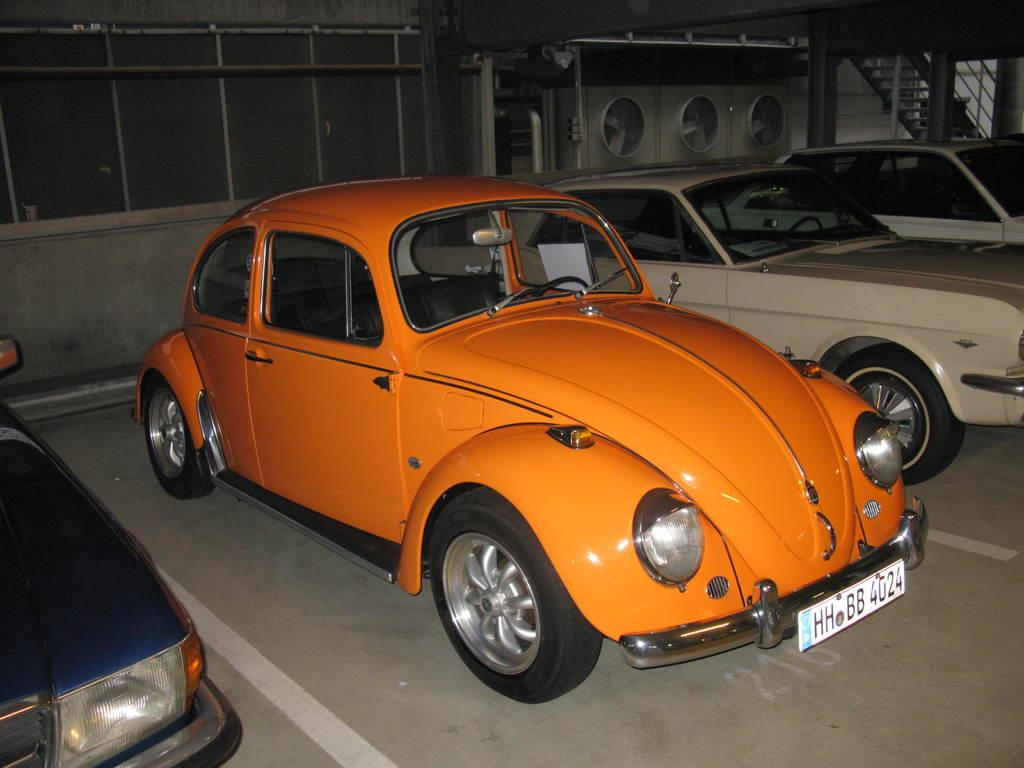What type of objects are featured in the image? There are model cars in the image. Where are the model cars located? The model cars are parked in a parking area. What architectural feature can be seen in the image? There are stairs visible in the image. What other object can be seen in the image? There is a machine-like object in the image. What structural elements are present in the image? There are pillars in the image. Can you describe the curtain hanging from the machine-like object in the image? There is no curtain present in the image; the machine-like object does not have any curtains hanging from it. 